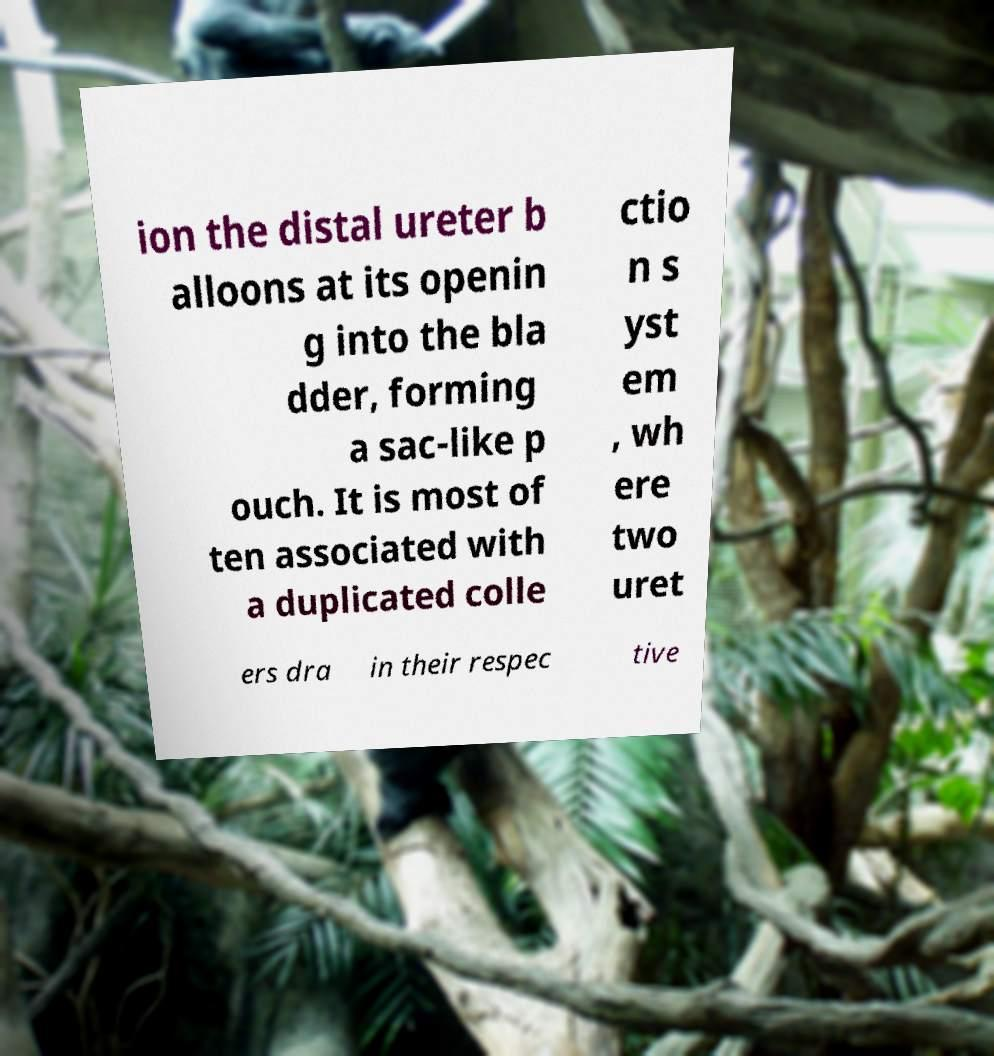Can you read and provide the text displayed in the image?This photo seems to have some interesting text. Can you extract and type it out for me? ion the distal ureter b alloons at its openin g into the bla dder, forming a sac-like p ouch. It is most of ten associated with a duplicated colle ctio n s yst em , wh ere two uret ers dra in their respec tive 